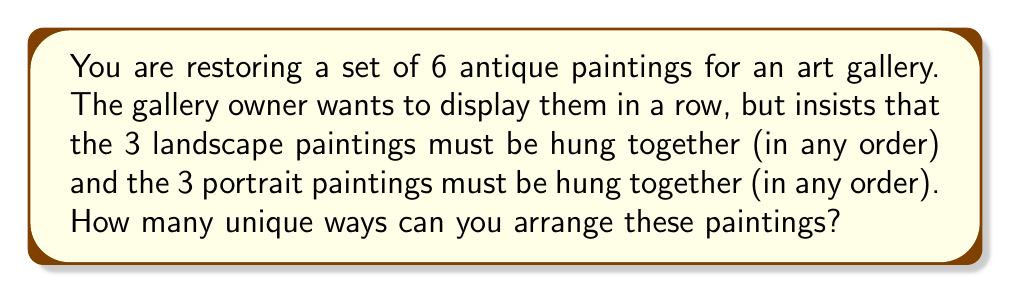Can you solve this math problem? Let's approach this step-by-step using permutation groups:

1) First, we can consider the landscape group and portrait group as two distinct units. So, we have 2! ways to arrange these two groups:

   $$(2!) = 2$$

2) Now, within the landscape group, we have 3! ways to arrange the 3 paintings:

   $$(3!) = 6$$

3) Similarly, within the portrait group, we have 3! ways to arrange the 3 paintings:

   $$(3!) = 6$$

4) By the multiplication principle, the total number of unique arrangements is the product of these individual arrangements:

   $$2 \times 3! \times 3! = 2 \times 6 \times 6 = 72$$

This problem demonstrates the concept of permutation groups. We're treating the landscape and portrait groups as elements of a larger permutation, while also considering the permutations within each group.

In group theory terms, this is an example of the wreath product of symmetric groups:

$$S_2 \wr S_3 = S_2 \ltimes (S_3 \times S_3)$$

Where $S_2$ represents the permutation of the two main groups, and each $S_3$ represents the permutations within each group.
Answer: 72 unique arrangements 